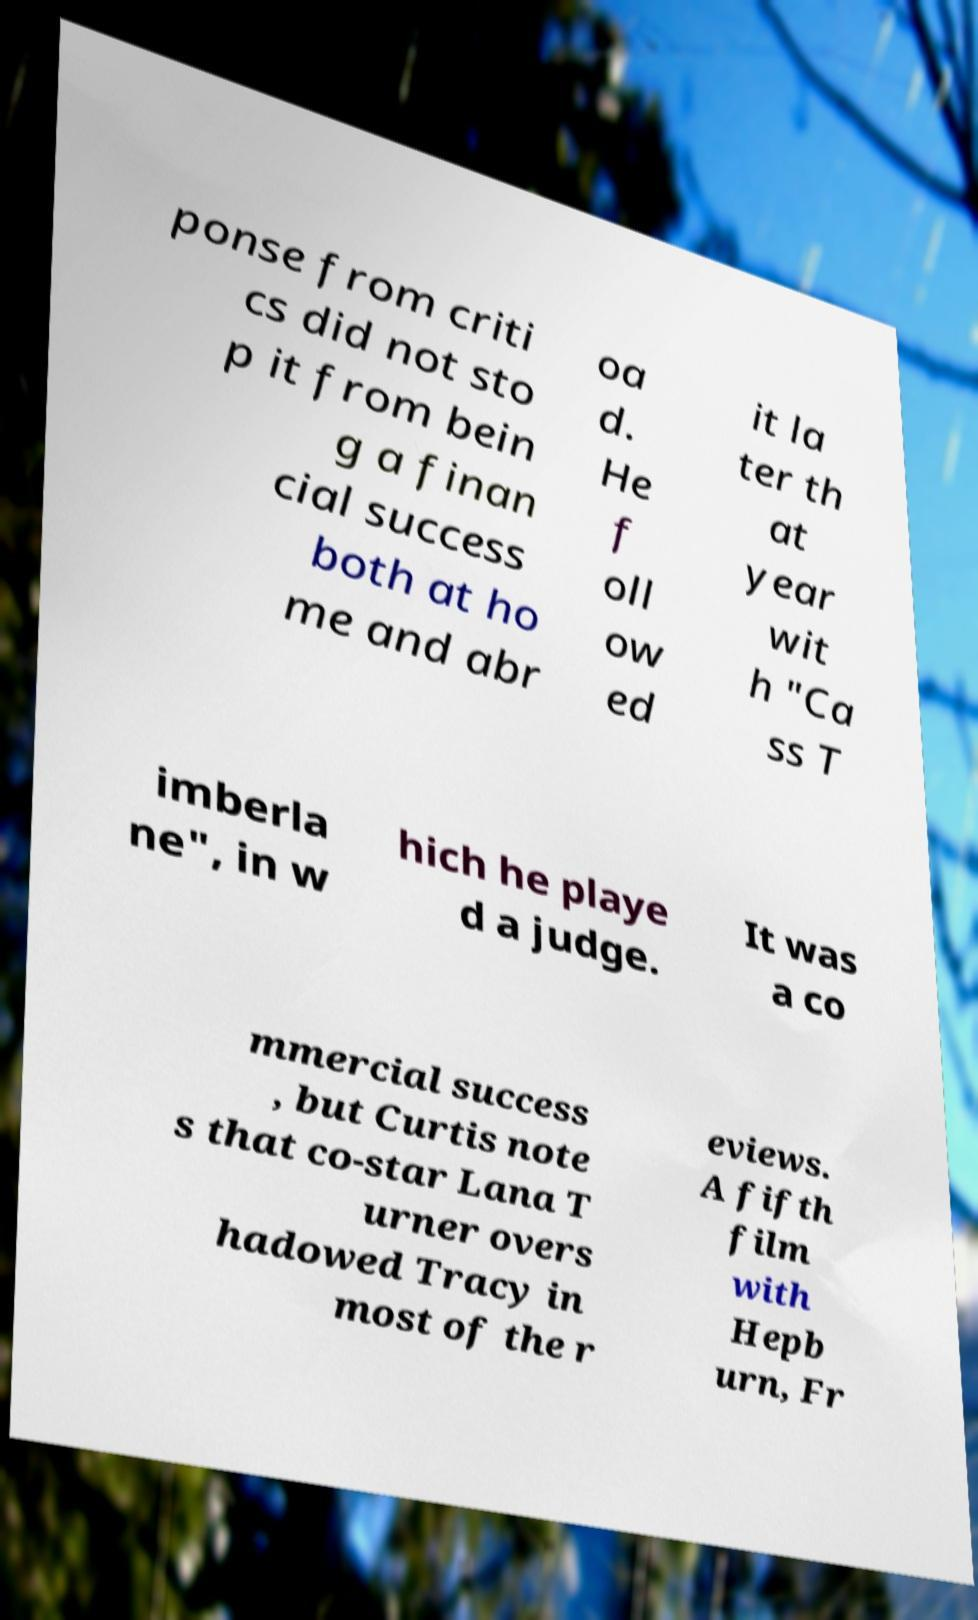Could you assist in decoding the text presented in this image and type it out clearly? ponse from criti cs did not sto p it from bein g a finan cial success both at ho me and abr oa d. He f oll ow ed it la ter th at year wit h "Ca ss T imberla ne", in w hich he playe d a judge. It was a co mmercial success , but Curtis note s that co-star Lana T urner overs hadowed Tracy in most of the r eviews. A fifth film with Hepb urn, Fr 